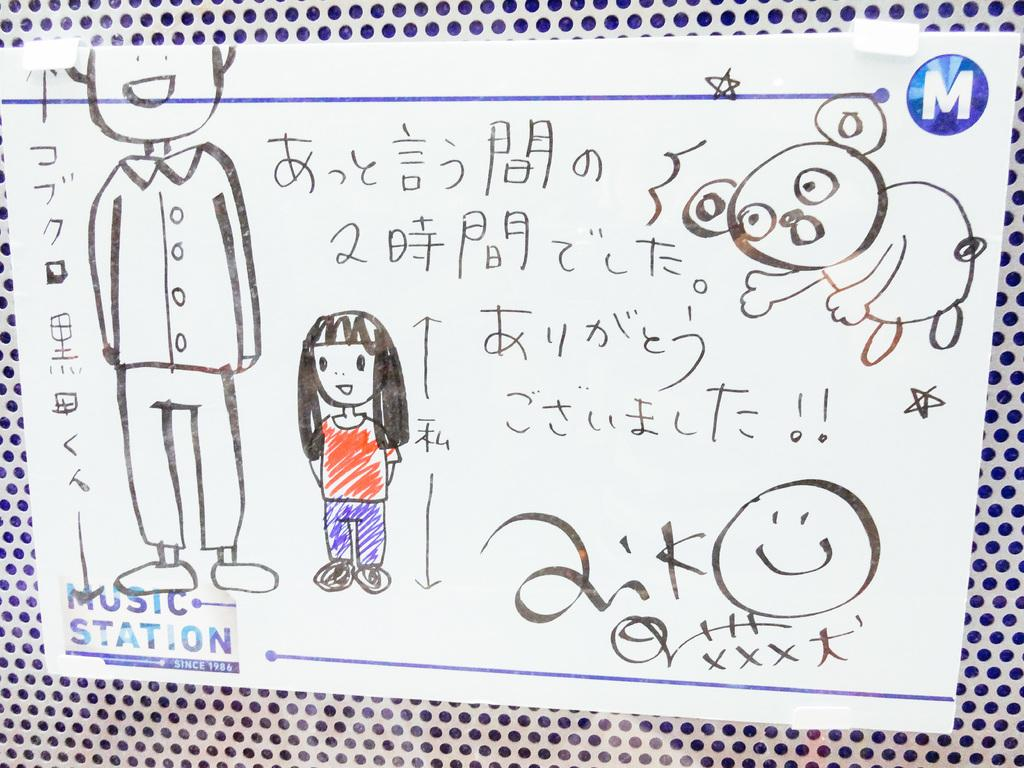What can be found on the paper in the image? There are drawings and words on the paper. Are there any additional features on the paper? Yes, the paper has stamp marks. What is the paper placed on? The paper is placed on an object. What is the weight of the pie in the image? There is no pie present in the image, so it is not possible to determine its weight. 